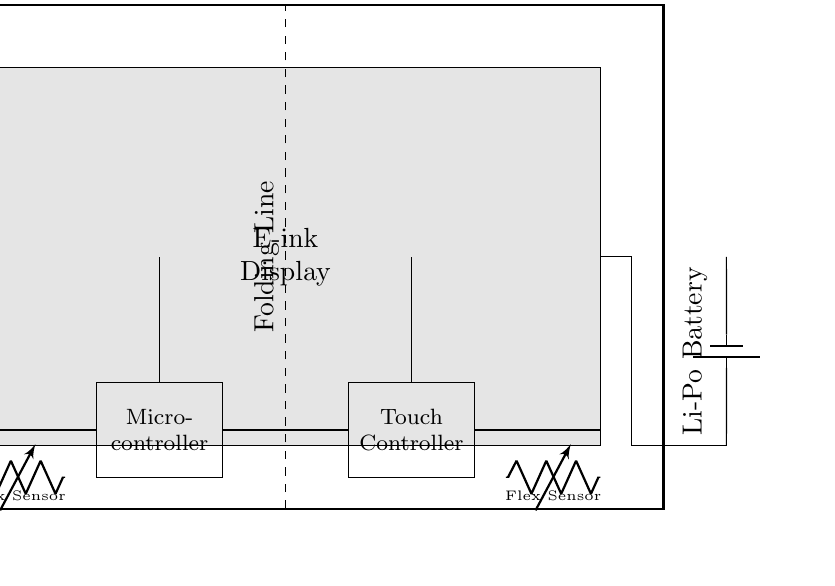What is the main component used for the display? The main component used for the display is an E-ink Display, which is represented as a large gray rectangle in the circuit diagram.
Answer: E-ink Display What is the type of battery connected in the circuit? The battery used in the circuit is a Lithium Polymer (Li-Po) Battery. This is indicated by the symbol showing a battery with the label beside it.
Answer: Li-Po Battery How many flex sensors are present in the circuit? There are two flex sensors present in the circuit, one on either side of the flexible printed circuit. Each is represented by a variable resistor symbol in the diagram.
Answer: Two What component connects the battery to the display? The component connecting the battery to the display is the flexible printed circuit itself, which serves as the interconnecting medium.
Answer: Flexible Printed Circuit What is the purpose of the touch controller in this circuit? The touch controller in this circuit processes inputs from the user's touch on the E-ink Display, signaling the microcontroller for further actions. This function is vital for user interaction and input recognition.
Answer: User interaction What does the dashed line represent in the circuit? The dashed line indicates the folding line of the flexible printed circuit, showing how the circuit can physically fold to accommodate the device's design, such as in a foldable e-reader.
Answer: Folding Line Which component is responsible for processing control signals? The component responsible for processing control signals is the microcontroller, which coordinates the operation of the display, sensors, and touch interface, managing the functionality of the e-reader.
Answer: Micro-controller 